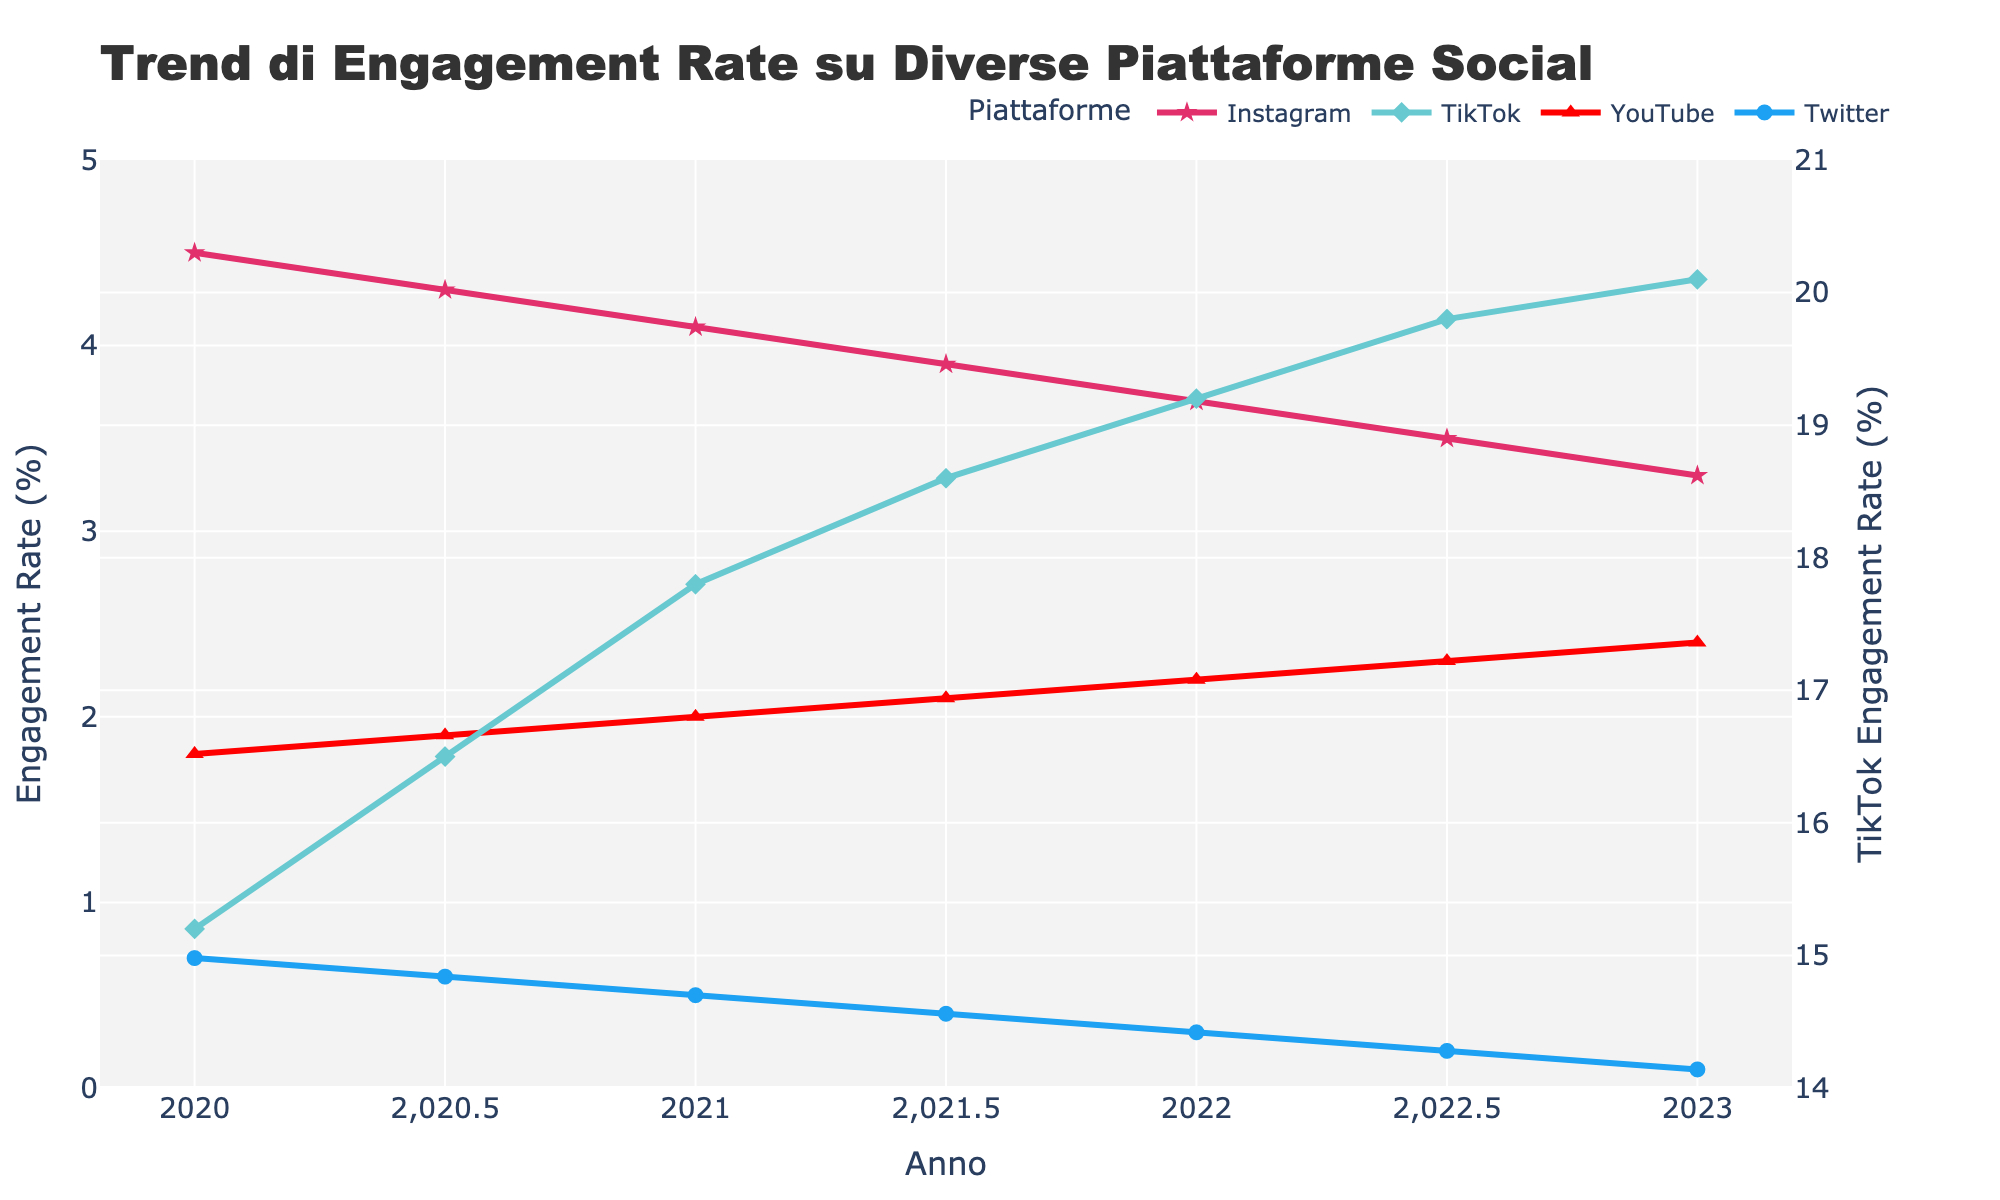What platform had the highest engagement rate in 2020? Observing the engagement rates for all platforms in 2020 shows TikTok had the highest engagement rate of 15.2.
Answer: TikTok Between 2020 and 2023, which platform showed a decreasing trend in engagement rate? By looking at the trend lines, Instagram and Twitter showed a decreasing trend in engagement rate from 2020 to 2023.
Answer: Instagram and Twitter What was the engagement rate difference between TikTok and YouTube in 2022? In 2022, TikTok had an engagement rate of 19.2, and YouTube had 2.2. The difference is calculated as 19.2 - 2.2 = 17.
Answer: 17 Which platform's engagement rate remained below 1% throughout the last 3 years? Observing the engagement rates, Twitter's engagement rate remained below 1% from 2020 to 2023.
Answer: Twitter How did the engagement rate for Instagram change from 2020 to 2023? Instagram's engagement rate dropped from 4.5 in 2020 to 3.3 in 2023. This is a decrease of 4.5 - 3.3 = 1.2.
Answer: Decreased by 1.2 Which platform showed the most consistent increase in engagement rate over the last 3 years? TikTok showed a consistent increase in engagement rate, starting at 15.2 in 2020 and reaching 20.1 in 2023.
Answer: TikTok What are the colors used to represent the engagement rates of Instagram, TikTok, YouTube, and Twitter? Instagram is represented by pink, TikTok by light blue, YouTube by red, and Twitter by blue based on their respective lines and markers.
Answer: Instagram: pink, TikTok: light blue, YouTube: red, Twitter: blue What is the average engagement rate for YouTube over the period 2020 to 2023? The engagement rates for YouTube are 1.8, 1.9, 2.0, 2.1, 2.2, 2.3, and 2.4. The average is computed as (1.8 + 1.9 + 2.0 + 2.1 + 2.2 + 2.3 + 2.4) / 7 = 2.1
Answer: 2.1 How did Twitter's engagement rate change between 2020 and 2022.5? Twitter's engagement rate dropped from 0.7 in 2020 to 0.2 in 2022.5. This is a decrease of 0.7 - 0.2 = 0.5.
Answer: Decreased by 0.5 